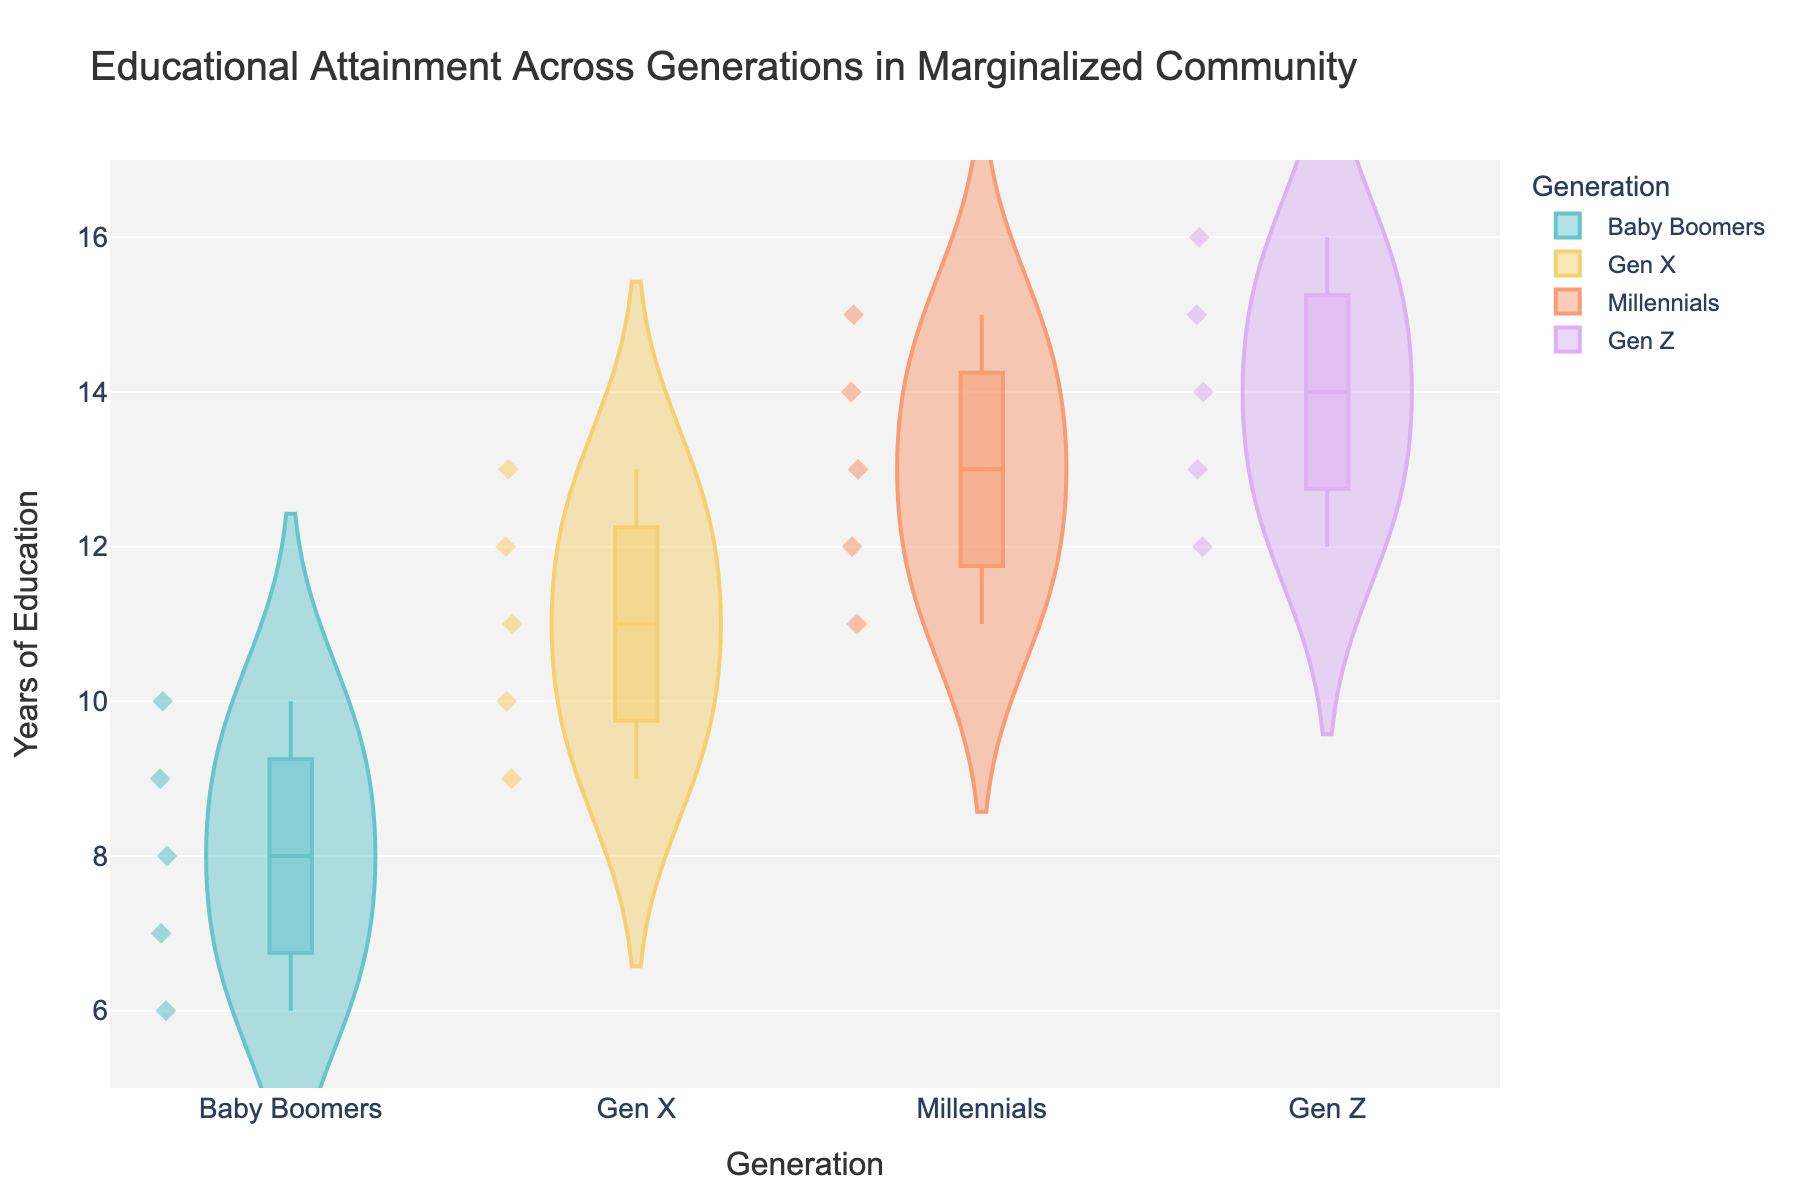What is the title of the plot? The title of the plot is usually located at the top of the figure in a larger font. It provides an overview of the data being visualized.
Answer: Educational Attainment Across Generations in Marginalized Community How many generations are represented in the plot? By observing the x-axis labels, you can count the distinct categories represented.
Answer: 4 Which generation has the highest median years of education? In a violin plot with a box inside, the median is represented by a line inside the box. The generation with the highest median will have the highest positioning of the median line.
Answer: Gen Z What are the minimum and maximum education years observed in the plot? The violin plot shows the distribution with the whiskers of the box plot representing the minimum and maximum values.
Answer: Minimum: 6, Maximum: 16 Compare the median years of education between Baby Boomers and Millennials. The median for each generation is the line within the box. Note the relative height of these lines for the two generations and compare.
Answer: Millennials have a higher median Which generation shows the greatest variability in education years? The variability can be assessed by looking at the height and spread of the violin plots. A wider and more spread-out plot indicates greater variability.
Answer: Gen Z Is there any generation for which all data points have been plotted on the same education year? Look for a violin plot where all the points overlap or cluster without much spread.
Answer: No Between Gen X and Gen Z, which generation has more data points above 13 years of education? Count the individual points plotted above 13 years in each generation’s violin plot.
Answer: Gen Z What is the interquartile range for Gen X? The interquartile range (IQR) is the range between the 25th and 75th percentile, seen as the height of the box in the boxplot within the violin plot.
Answer: 11 - 9 = 2 Does any generation have data points that could be considered outliers? In violin plots, outliers are typically shown as points outside the whiskers of the box plot. Look for such points in each generation.
Answer: No 